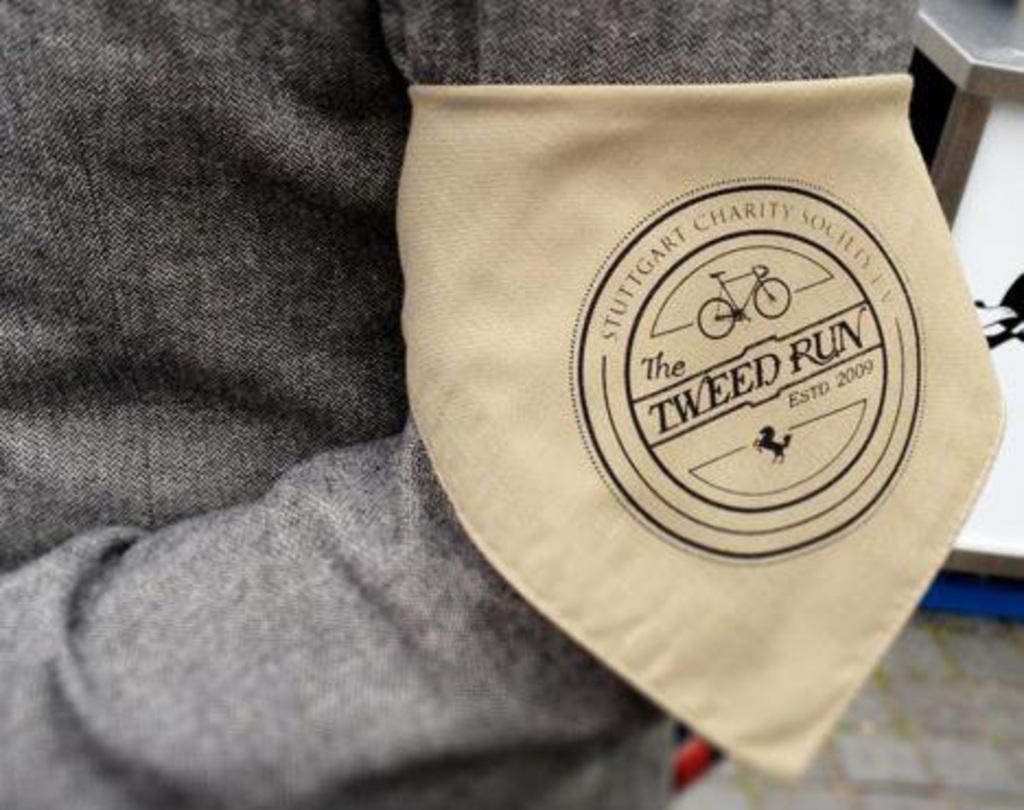Could you give a brief overview of what you see in this image? In front of the picture, we see a grey color cloth and we see a cream color cloth with some text written on it. I think it is the hand of the person. On the right side, we see a sop or a building in white color. 